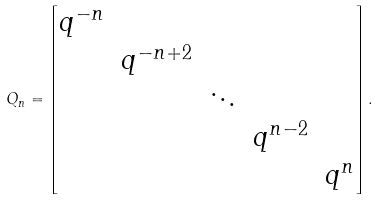<formula> <loc_0><loc_0><loc_500><loc_500>Q _ { n } = \begin{bmatrix} q ^ { - n } \\ & q ^ { - n + 2 } \\ & & \ddots \\ & & & q ^ { n - 2 } \\ & & & & q ^ { n } \end{bmatrix} .</formula> 